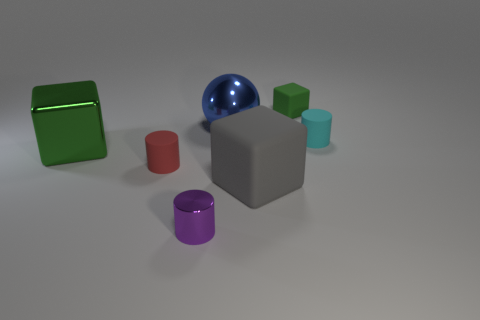What is the material that makes up the blue object, and how does its surface appear? The blue object appears to be made of a reflective material, possibly a polished metal or smooth plastic, as evidenced by the way it catches the light and reflects its surroundings. 